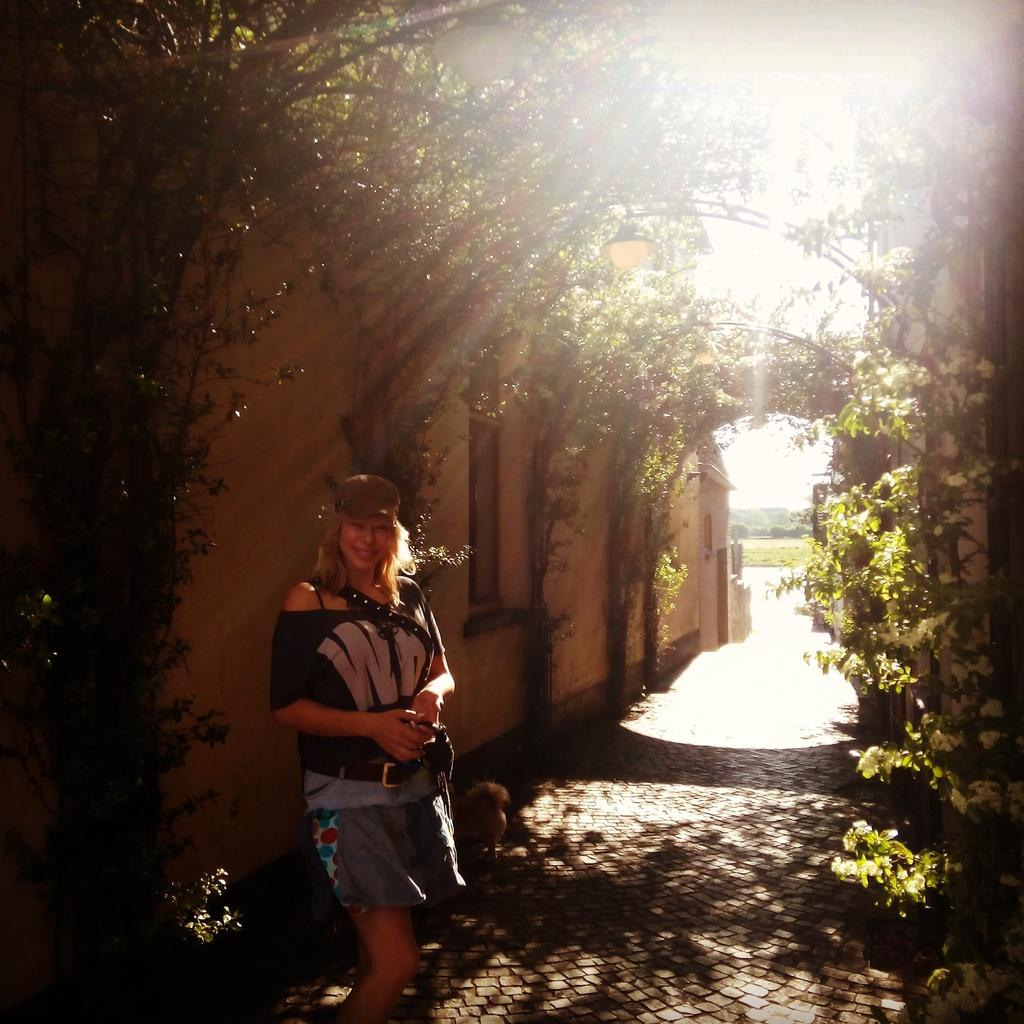Who is present in the image? There is a woman standing in the image. Where is the woman located in the image? The woman is at the bottom of the image. What can be seen in the background of the image? There are trees and buildings in the background of the image. What type of cheese is the woman holding in the image? There is no cheese present in the image; the woman is not holding anything. Is the woman's uncle visible in the image? There is no mention of an uncle in the image, and no one else is visible besides the woman. 